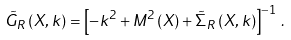<formula> <loc_0><loc_0><loc_500><loc_500>\tilde { G } _ { R } \left ( X , k \right ) = \left [ - k ^ { 2 } + M ^ { 2 } \left ( X \right ) + \tilde { \Sigma } _ { R } \left ( X , k \right ) \right ] ^ { - 1 } \, .</formula> 